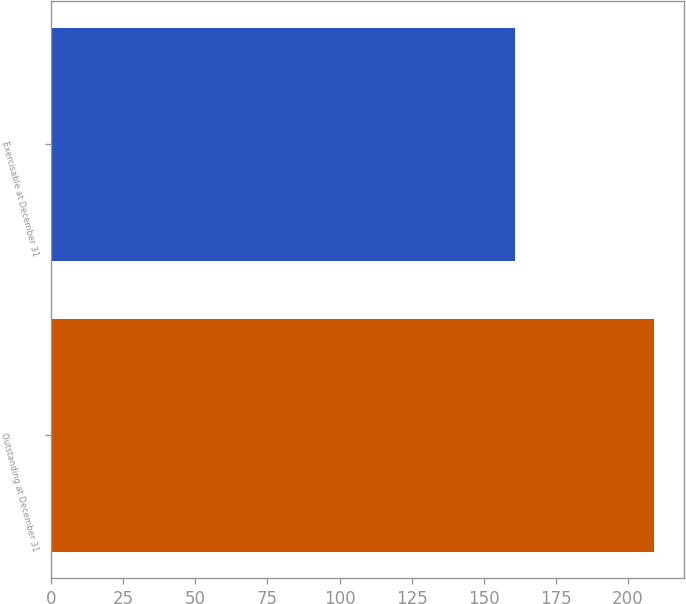Convert chart to OTSL. <chart><loc_0><loc_0><loc_500><loc_500><bar_chart><fcel>Outstanding at December 31<fcel>Exercisable at December 31<nl><fcel>209<fcel>161<nl></chart> 